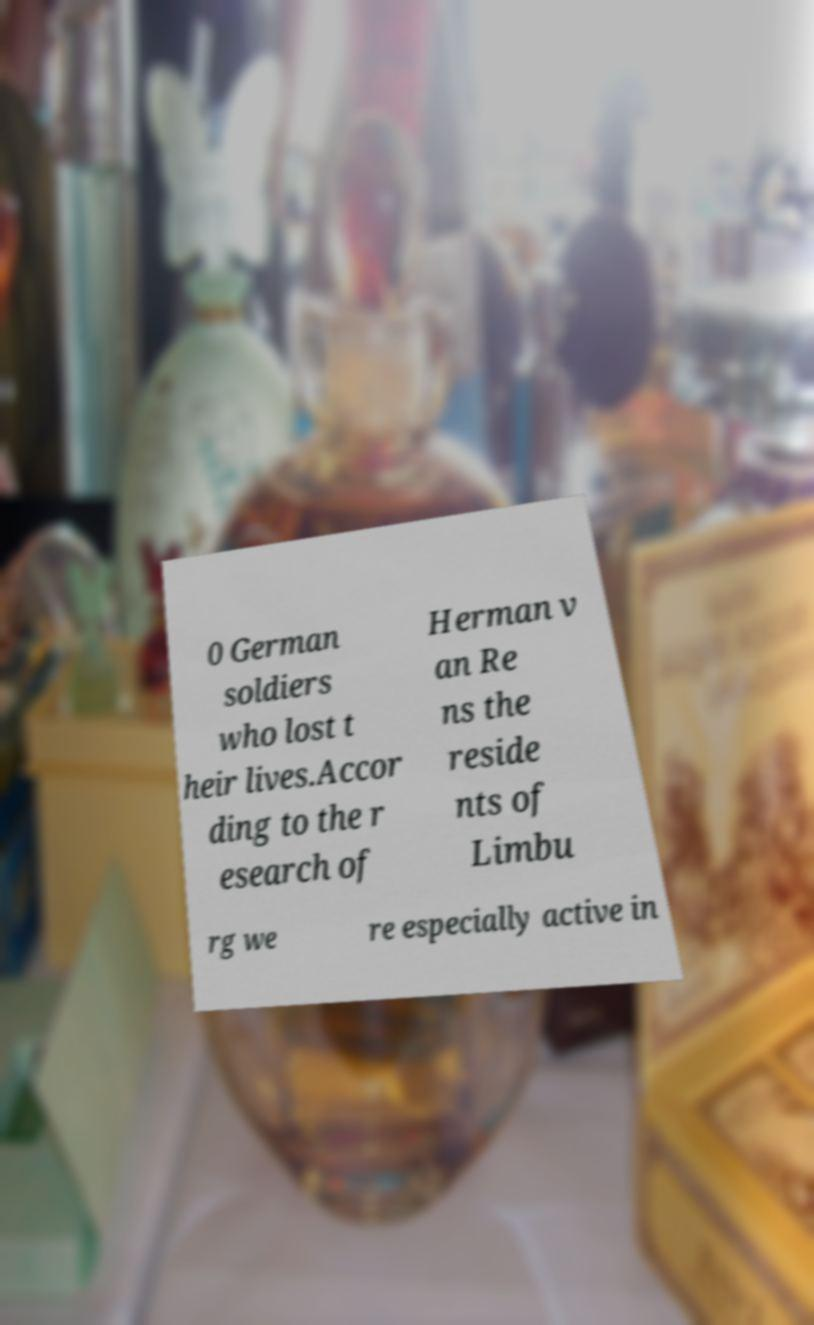Please read and relay the text visible in this image. What does it say? 0 German soldiers who lost t heir lives.Accor ding to the r esearch of Herman v an Re ns the reside nts of Limbu rg we re especially active in 